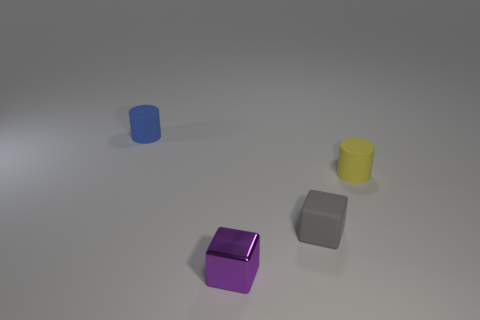What material is the small purple thing that is on the right side of the tiny cylinder to the left of the small cube left of the gray object made of?
Ensure brevity in your answer.  Metal. Does the blue object have the same size as the cylinder in front of the blue object?
Keep it short and to the point. Yes. Is there a tiny cylinder of the same color as the tiny metallic cube?
Give a very brief answer. No. There is a cylinder that is behind the rubber cylinder on the right side of the rubber cube; what color is it?
Your answer should be very brief. Blue. Is the number of purple objects on the left side of the small blue thing less than the number of objects right of the small gray rubber thing?
Provide a succinct answer. Yes. Do the gray thing and the yellow rubber cylinder have the same size?
Provide a succinct answer. Yes. What is the shape of the thing that is both in front of the yellow rubber object and behind the purple metal object?
Provide a succinct answer. Cube. How many blue objects have the same material as the small purple cube?
Ensure brevity in your answer.  0. What number of purple cubes are behind the rubber cylinder that is to the left of the small yellow cylinder?
Give a very brief answer. 0. There is a small yellow rubber object that is on the right side of the matte thing behind the small matte cylinder that is on the right side of the blue cylinder; what is its shape?
Offer a terse response. Cylinder. 